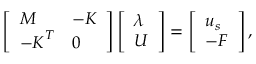<formula> <loc_0><loc_0><loc_500><loc_500>\begin{array} { r } { \left [ \begin{array} { l l } { M } & { - K } \\ { - K ^ { T } } & { 0 } \end{array} \right ] \left [ \begin{array} { l } { \lambda } \\ { U } \end{array} \right ] = \left [ \begin{array} { l } { u _ { s } } \\ { - F } \end{array} \right ] , } \end{array}</formula> 